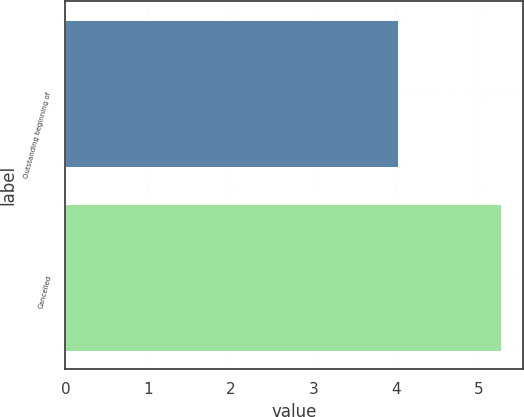<chart> <loc_0><loc_0><loc_500><loc_500><bar_chart><fcel>Outstanding beginning of<fcel>Cancelled<nl><fcel>4.02<fcel>5.27<nl></chart> 